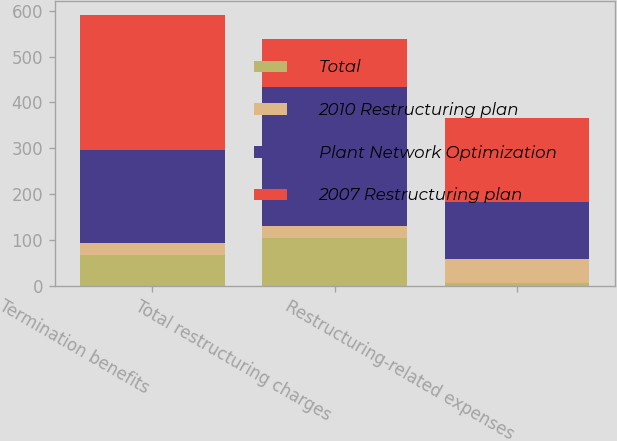Convert chart. <chart><loc_0><loc_0><loc_500><loc_500><stacked_bar_chart><ecel><fcel>Termination benefits<fcel>Total restructuring charges<fcel>Restructuring-related expenses<nl><fcel>Total<fcel>66<fcel>105<fcel>5<nl><fcel>2010 Restructuring plan<fcel>26<fcel>26<fcel>53<nl><fcel>Plant Network Optimization<fcel>204<fcel>302<fcel>125<nl><fcel>2007 Restructuring plan<fcel>296<fcel>105<fcel>183<nl></chart> 